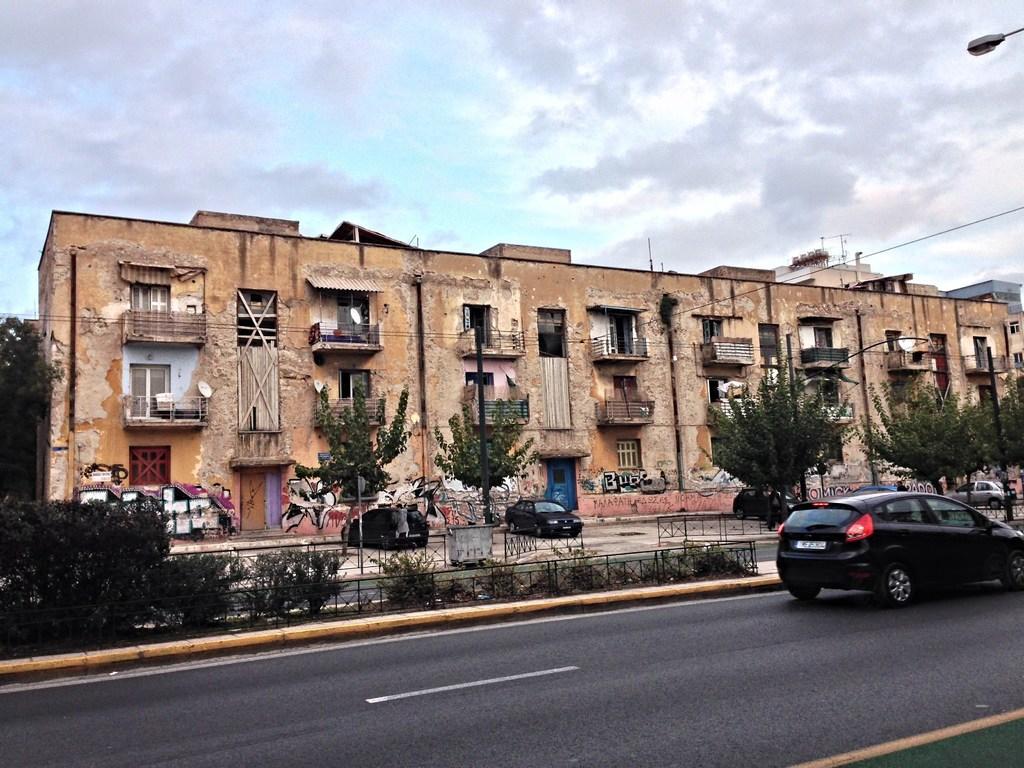Can you describe this image briefly? In this picture we can see the buildings, windows, balconies, pipes, trees, graffiti on the wall, cars, railings, plants, wires. At the top of the image we can see the clouds are present in the sky. In the top right corner we can see an electric light. At the bottom of the image we can see the road. 